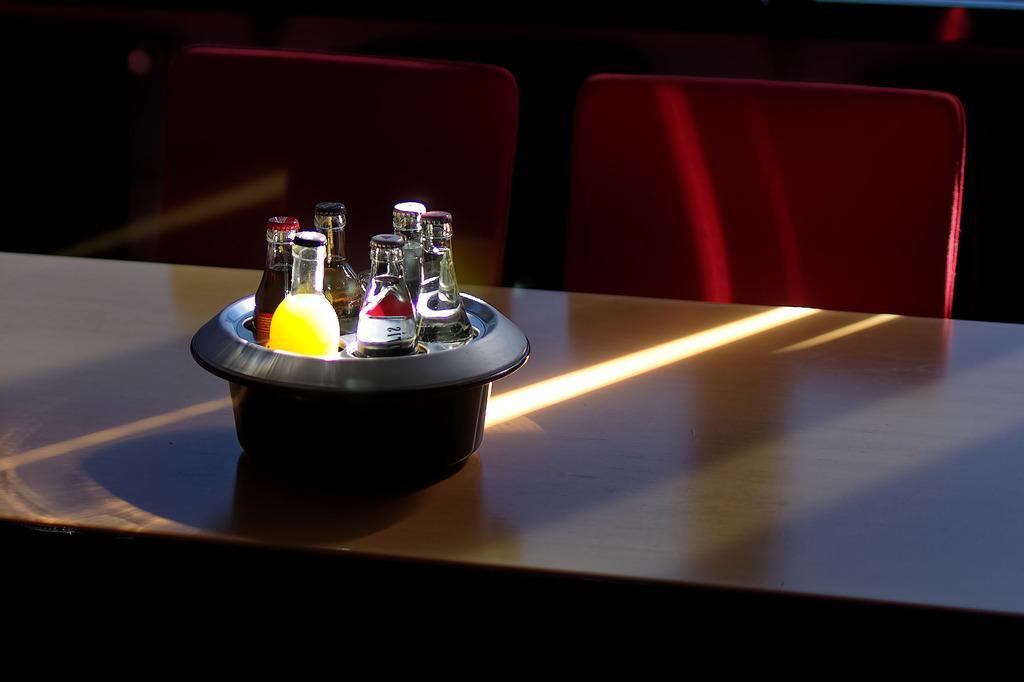How would you summarize this image in a sentence or two? This picture shows a bottles which were packed in the bowl, on the table. There are two chairs in front of the table. 